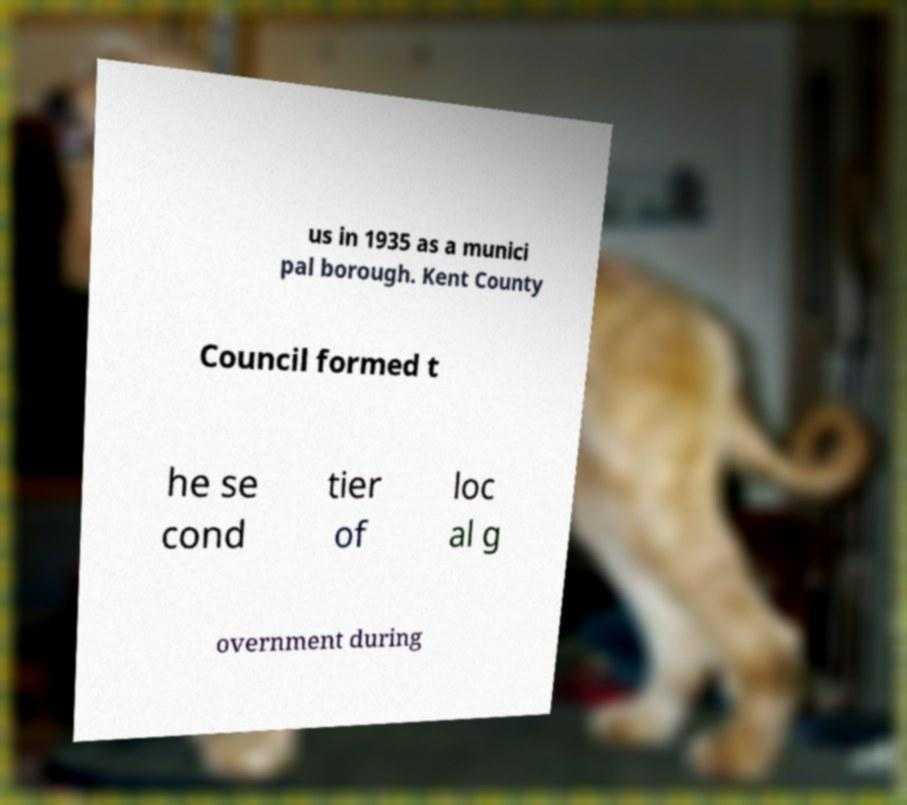There's text embedded in this image that I need extracted. Can you transcribe it verbatim? us in 1935 as a munici pal borough. Kent County Council formed t he se cond tier of loc al g overnment during 